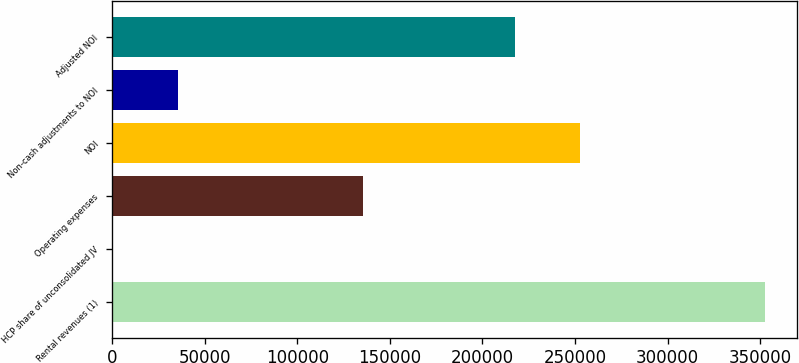Convert chart to OTSL. <chart><loc_0><loc_0><loc_500><loc_500><bar_chart><fcel>Rental revenues (1)<fcel>HCP share of unconsolidated JV<fcel>Operating expenses<fcel>NOI<fcel>Non-cash adjustments to NOI<fcel>Adjusted NOI<nl><fcel>352442<fcel>571<fcel>135375<fcel>252626<fcel>35758.1<fcel>217439<nl></chart> 